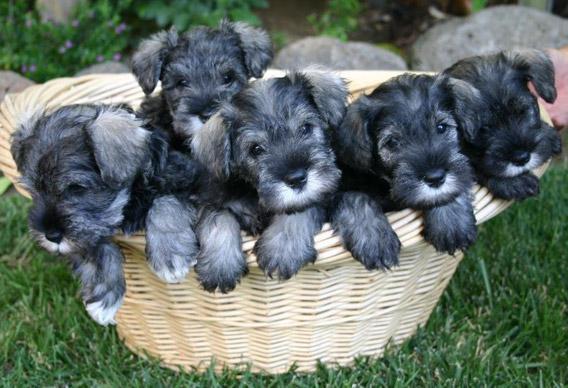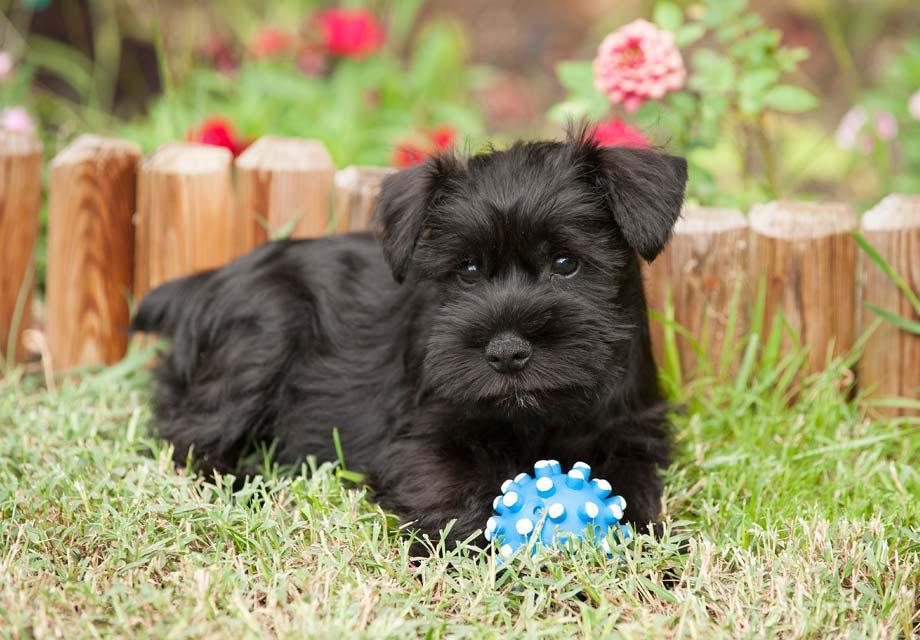The first image is the image on the left, the second image is the image on the right. Considering the images on both sides, is "There is at least collar in the image on the left." valid? Answer yes or no. No. 